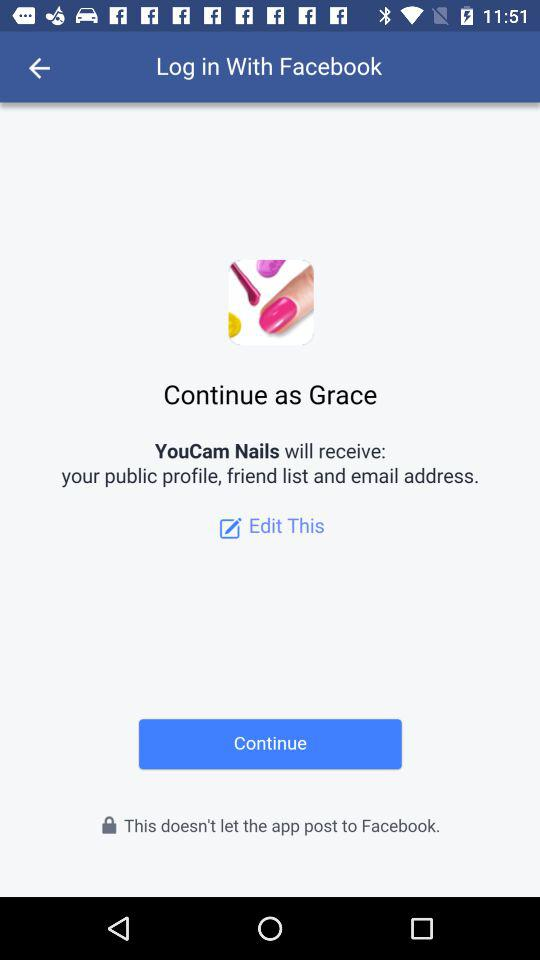What application is asking for permission? The application "YouCam Nails" is asking for permission. 